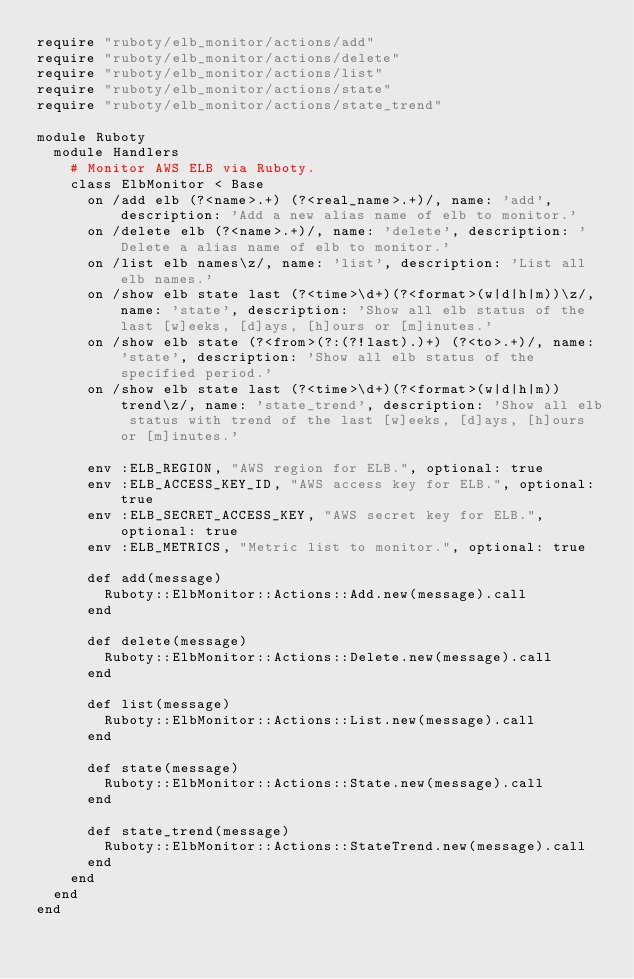<code> <loc_0><loc_0><loc_500><loc_500><_Ruby_>require "ruboty/elb_monitor/actions/add"
require "ruboty/elb_monitor/actions/delete"
require "ruboty/elb_monitor/actions/list"
require "ruboty/elb_monitor/actions/state"
require "ruboty/elb_monitor/actions/state_trend"

module Ruboty
  module Handlers
    # Monitor AWS ELB via Ruboty.
    class ElbMonitor < Base
      on /add elb (?<name>.+) (?<real_name>.+)/, name: 'add', description: 'Add a new alias name of elb to monitor.'
      on /delete elb (?<name>.+)/, name: 'delete', description: 'Delete a alias name of elb to monitor.'
      on /list elb names\z/, name: 'list', description: 'List all elb names.'
      on /show elb state last (?<time>\d+)(?<format>(w|d|h|m))\z/, name: 'state', description: 'Show all elb status of the last [w]eeks, [d]ays, [h]ours or [m]inutes.'
      on /show elb state (?<from>(?:(?!last).)+) (?<to>.+)/, name: 'state', description: 'Show all elb status of the specified period.'
      on /show elb state last (?<time>\d+)(?<format>(w|d|h|m)) trend\z/, name: 'state_trend', description: 'Show all elb status with trend of the last [w]eeks, [d]ays, [h]ours or [m]inutes.'

      env :ELB_REGION, "AWS region for ELB.", optional: true
      env :ELB_ACCESS_KEY_ID, "AWS access key for ELB.", optional: true
      env :ELB_SECRET_ACCESS_KEY, "AWS secret key for ELB.", optional: true
      env :ELB_METRICS, "Metric list to monitor.", optional: true

      def add(message)
        Ruboty::ElbMonitor::Actions::Add.new(message).call
      end

      def delete(message)
        Ruboty::ElbMonitor::Actions::Delete.new(message).call
      end

      def list(message)
        Ruboty::ElbMonitor::Actions::List.new(message).call
      end

      def state(message)
        Ruboty::ElbMonitor::Actions::State.new(message).call
      end

      def state_trend(message)
        Ruboty::ElbMonitor::Actions::StateTrend.new(message).call
      end
    end
  end
end
</code> 